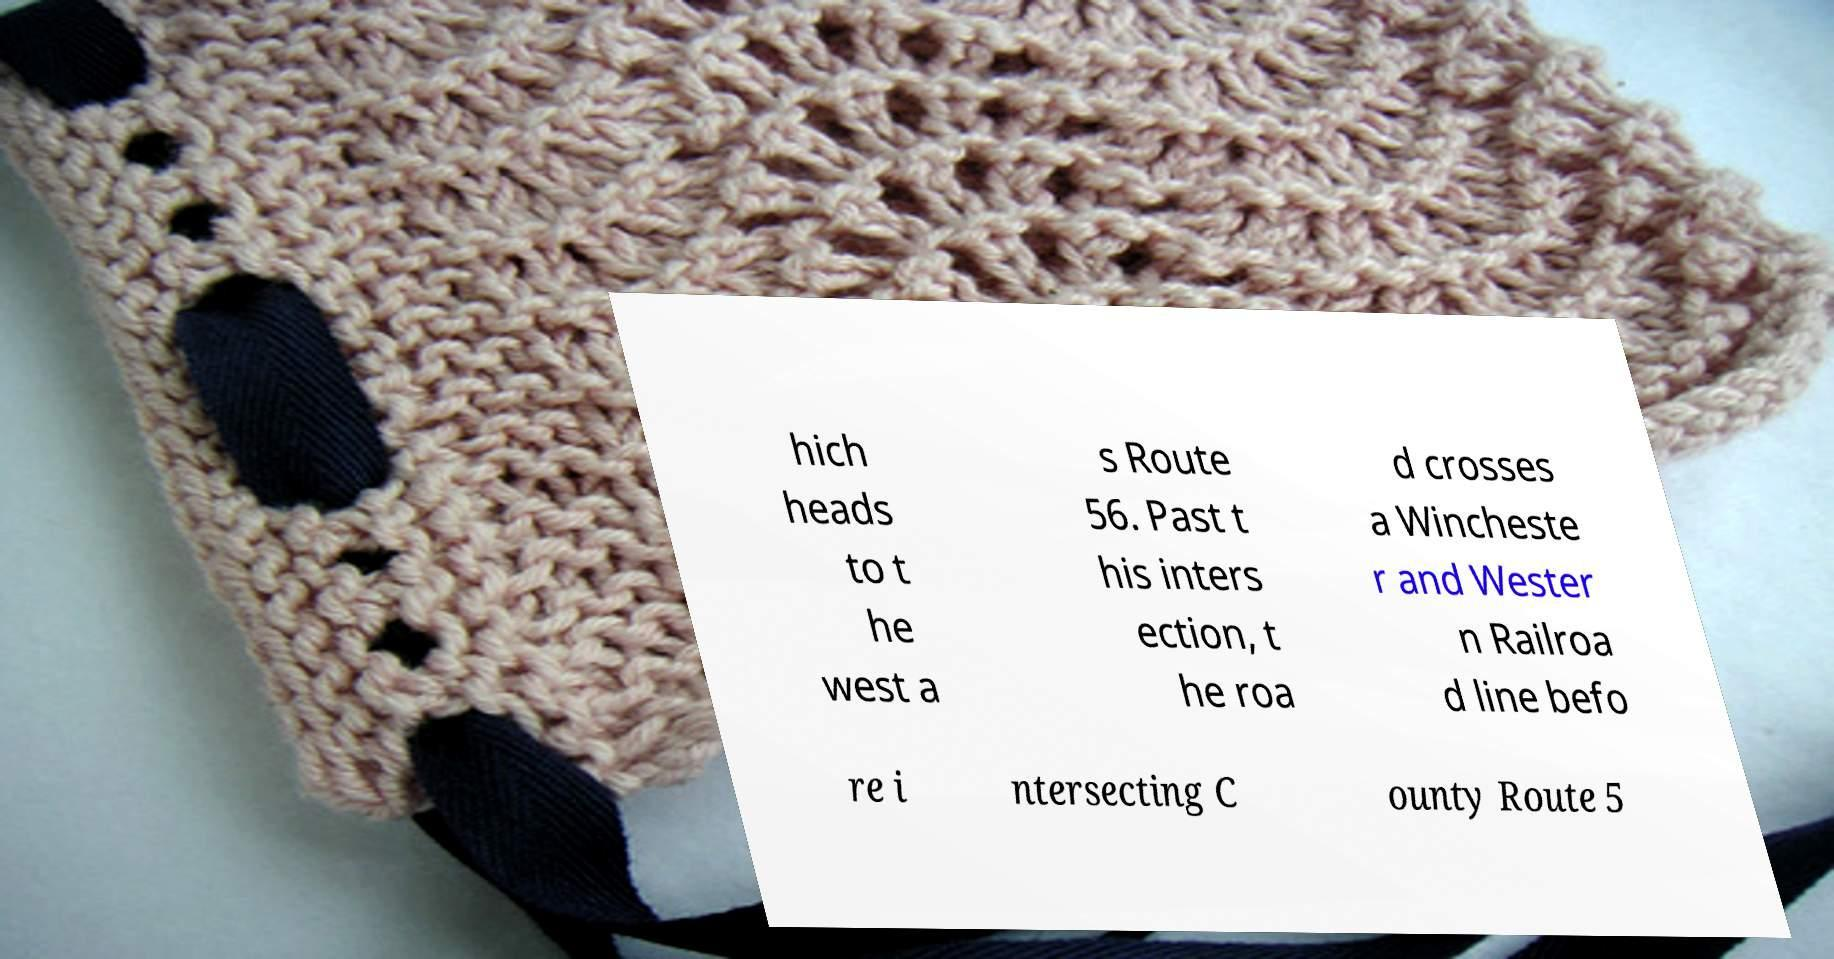There's text embedded in this image that I need extracted. Can you transcribe it verbatim? hich heads to t he west a s Route 56. Past t his inters ection, t he roa d crosses a Wincheste r and Wester n Railroa d line befo re i ntersecting C ounty Route 5 